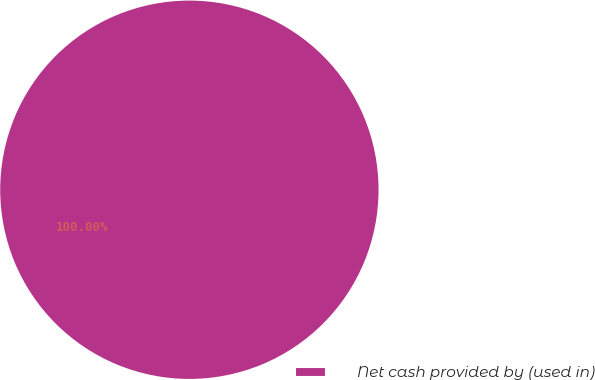Convert chart. <chart><loc_0><loc_0><loc_500><loc_500><pie_chart><fcel>Net cash provided by (used in)<nl><fcel>100.0%<nl></chart> 